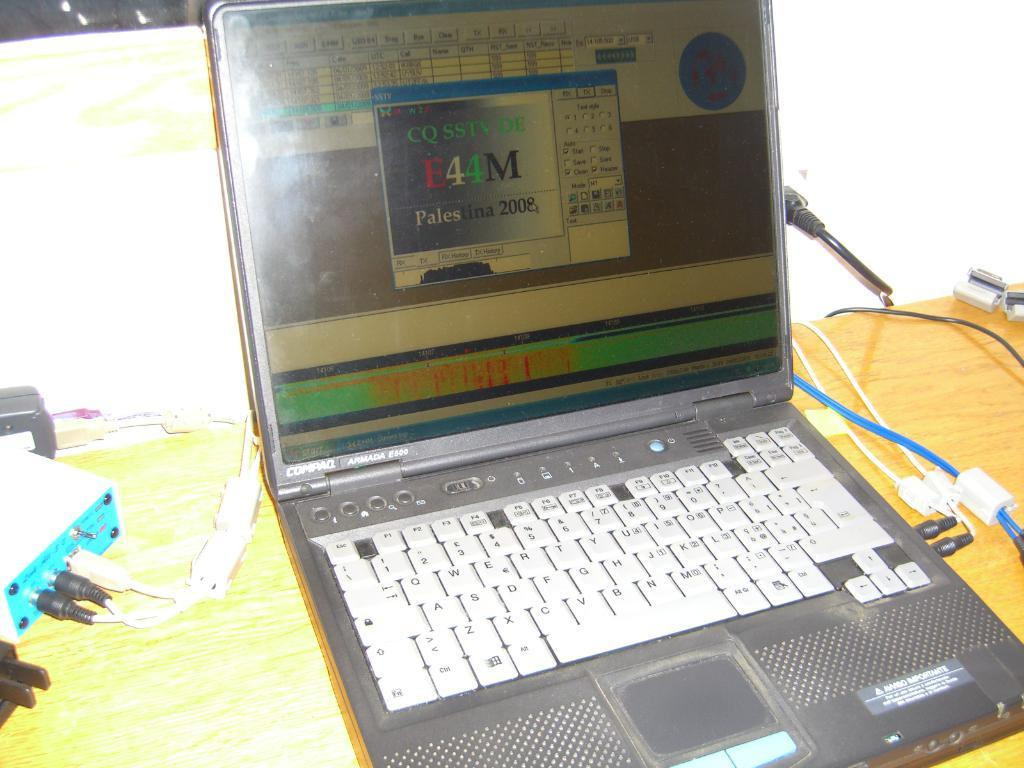<image>
Write a terse but informative summary of the picture. A program is open on a laptop made by Compaq. 